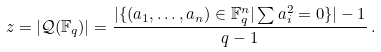Convert formula to latex. <formula><loc_0><loc_0><loc_500><loc_500>z = | \mathcal { Q } ( \mathbb { F } _ { q } ) | = \frac { | \{ ( a _ { 1 } , \dots , a _ { n } ) \in \mathbb { F } _ { q } ^ { n } | \sum a _ { i } ^ { 2 } = 0 \} | - 1 } { q - 1 } \, .</formula> 